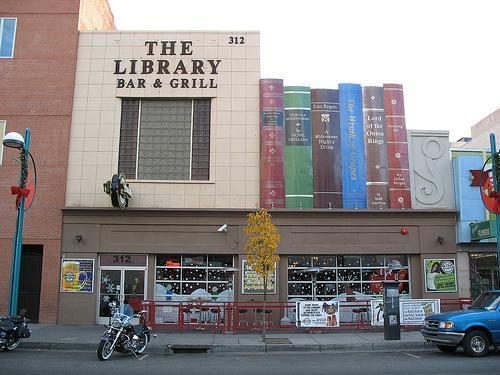How many motorbikes are there?
Give a very brief answer. 1. 